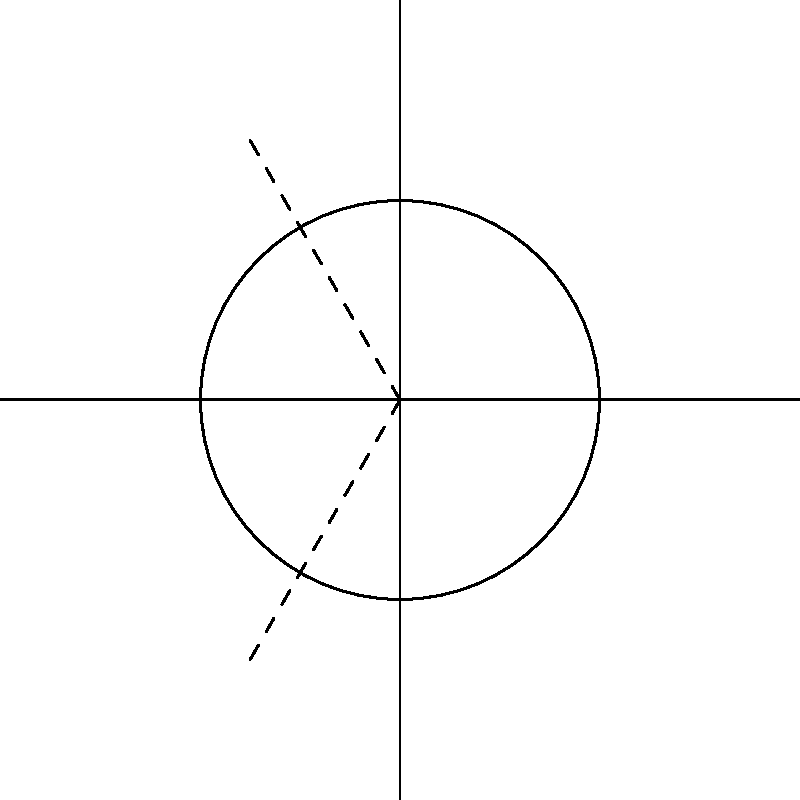In the diagram, three tangent lines are drawn to a circle at points A, B, and C. If the radius of the circle is 2 units and the distance OA is 3 units, what is the length of the tangent line segment from point A to its point of tangency on the circle? This geometric principle is similar to how the boundaries of Sikkim were determined in relation to its neighboring states and countries. To solve this problem, we'll use the properties of tangent lines to a circle:

1. A tangent line is perpendicular to the radius drawn to the point of tangency.
2. The tangent-radius theorem states that the tangent line segment is the mean proportional between the whole secant and its external part.

Let's follow these steps:

1. Consider the right triangle formed by OA and the tangent line from A.
2. Let x be the length of the tangent line segment.
3. The radius OT (where T is the point of tangency) is perpendicular to the tangent line AT.
4. We can use the Pythagorean theorem in triangle OAT:

   $$OA^2 = OT^2 + AT^2$$

5. Substitute the known values:

   $$3^2 = 2^2 + x^2$$

6. Simplify:

   $$9 = 4 + x^2$$

7. Solve for x:

   $$x^2 = 5$$
   $$x = \sqrt{5}$$

Therefore, the length of the tangent line segment from point A to its point of tangency is $\sqrt{5}$ units.

This geometric principle of tangent lines can be metaphorically related to how Sikkim's boundaries were determined, with the circle representing Sikkim and the tangent lines representing its borders with neighboring states and countries, each touching at a single point of contact.
Answer: $\sqrt{5}$ units 